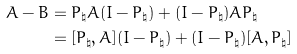Convert formula to latex. <formula><loc_0><loc_0><loc_500><loc_500>A - B & = P _ { \natural } A ( I - P _ { \natural } ) + ( I - P _ { \natural } ) A P _ { \natural } \\ & = [ P _ { \natural } , A ] ( I - P _ { \natural } ) + ( I - P _ { \natural } ) [ A , P _ { \natural } ]</formula> 